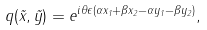Convert formula to latex. <formula><loc_0><loc_0><loc_500><loc_500>q ( \vec { x } , \vec { y } ) = e ^ { i \theta \epsilon ( \alpha x _ { 1 } + \beta x _ { 2 } - \alpha y _ { 1 } - \beta y _ { 2 } ) } ,</formula> 